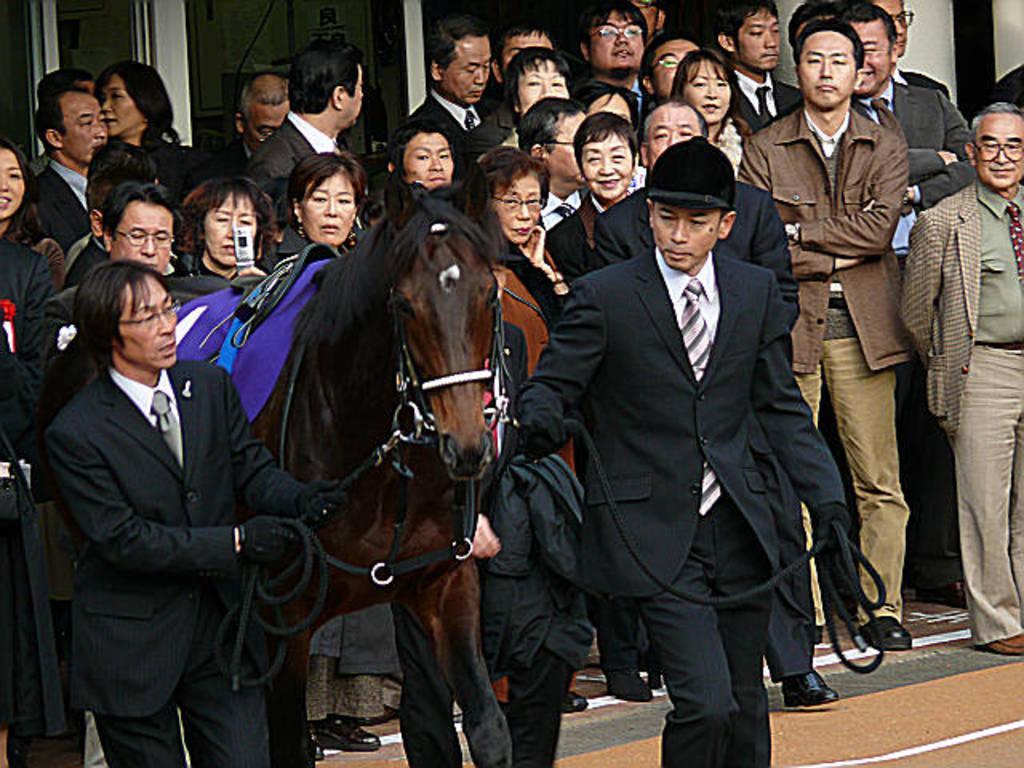Describe this image in one or two sentences. In the picture we can find some people are standing and two people are holding horse. The horse is brown in color with belts and top of it there is a blue color curtain, persons are wearing a black blazers,ties and shirts. 